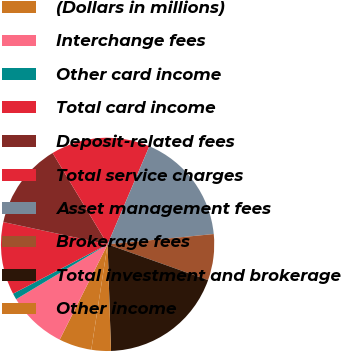Convert chart. <chart><loc_0><loc_0><loc_500><loc_500><pie_chart><fcel>(Dollars in millions)<fcel>Interchange fees<fcel>Other card income<fcel>Total card income<fcel>Deposit-related fees<fcel>Total service charges<fcel>Asset management fees<fcel>Brokerage fees<fcel>Total investment and brokerage<fcel>Other income<nl><fcel>4.97%<fcel>8.99%<fcel>0.94%<fcel>11.01%<fcel>13.02%<fcel>15.03%<fcel>17.05%<fcel>6.98%<fcel>19.06%<fcel>2.95%<nl></chart> 